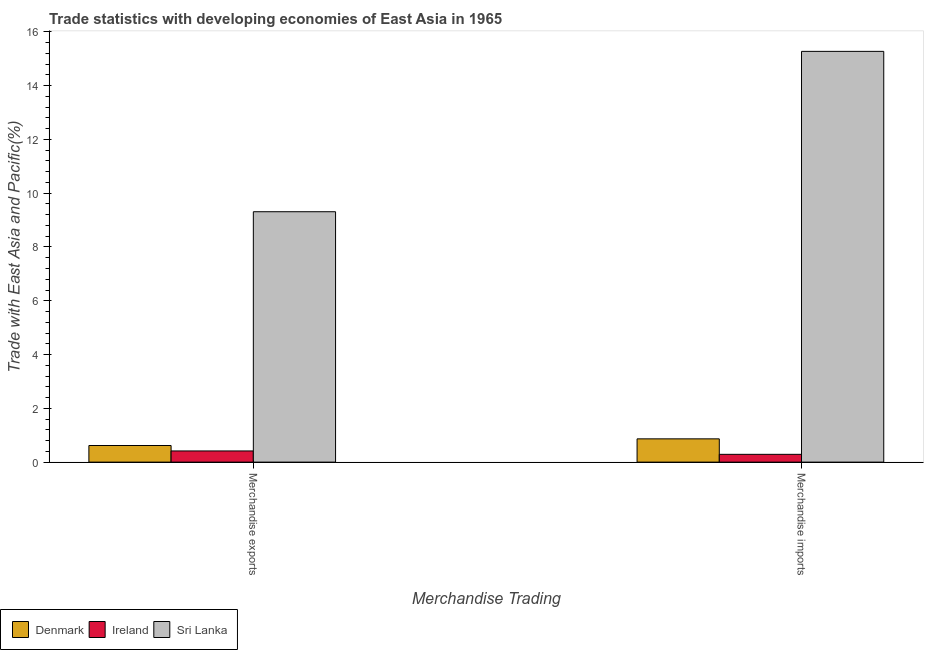How many different coloured bars are there?
Your answer should be compact. 3. How many groups of bars are there?
Your response must be concise. 2. How many bars are there on the 2nd tick from the left?
Offer a terse response. 3. What is the merchandise exports in Ireland?
Offer a terse response. 0.42. Across all countries, what is the maximum merchandise exports?
Offer a terse response. 9.31. Across all countries, what is the minimum merchandise exports?
Your answer should be very brief. 0.42. In which country was the merchandise exports maximum?
Offer a terse response. Sri Lanka. In which country was the merchandise imports minimum?
Your answer should be very brief. Ireland. What is the total merchandise exports in the graph?
Give a very brief answer. 10.34. What is the difference between the merchandise imports in Ireland and that in Denmark?
Make the answer very short. -0.58. What is the difference between the merchandise exports in Ireland and the merchandise imports in Sri Lanka?
Give a very brief answer. -14.86. What is the average merchandise imports per country?
Provide a short and direct response. 5.48. What is the difference between the merchandise exports and merchandise imports in Denmark?
Your answer should be very brief. -0.25. What is the ratio of the merchandise exports in Denmark to that in Sri Lanka?
Your answer should be very brief. 0.07. In how many countries, is the merchandise exports greater than the average merchandise exports taken over all countries?
Provide a short and direct response. 1. What does the 3rd bar from the left in Merchandise imports represents?
Your answer should be very brief. Sri Lanka. What does the 1st bar from the right in Merchandise imports represents?
Offer a very short reply. Sri Lanka. How many countries are there in the graph?
Your response must be concise. 3. What is the difference between two consecutive major ticks on the Y-axis?
Provide a succinct answer. 2. Are the values on the major ticks of Y-axis written in scientific E-notation?
Provide a short and direct response. No. Does the graph contain any zero values?
Provide a short and direct response. No. How many legend labels are there?
Keep it short and to the point. 3. What is the title of the graph?
Keep it short and to the point. Trade statistics with developing economies of East Asia in 1965. What is the label or title of the X-axis?
Your answer should be compact. Merchandise Trading. What is the label or title of the Y-axis?
Provide a succinct answer. Trade with East Asia and Pacific(%). What is the Trade with East Asia and Pacific(%) in Denmark in Merchandise exports?
Keep it short and to the point. 0.62. What is the Trade with East Asia and Pacific(%) in Ireland in Merchandise exports?
Your answer should be very brief. 0.42. What is the Trade with East Asia and Pacific(%) in Sri Lanka in Merchandise exports?
Your response must be concise. 9.31. What is the Trade with East Asia and Pacific(%) in Denmark in Merchandise imports?
Your response must be concise. 0.87. What is the Trade with East Asia and Pacific(%) in Ireland in Merchandise imports?
Your answer should be compact. 0.29. What is the Trade with East Asia and Pacific(%) in Sri Lanka in Merchandise imports?
Provide a succinct answer. 15.27. Across all Merchandise Trading, what is the maximum Trade with East Asia and Pacific(%) in Denmark?
Your answer should be compact. 0.87. Across all Merchandise Trading, what is the maximum Trade with East Asia and Pacific(%) in Ireland?
Offer a very short reply. 0.42. Across all Merchandise Trading, what is the maximum Trade with East Asia and Pacific(%) in Sri Lanka?
Provide a short and direct response. 15.27. Across all Merchandise Trading, what is the minimum Trade with East Asia and Pacific(%) of Denmark?
Your answer should be compact. 0.62. Across all Merchandise Trading, what is the minimum Trade with East Asia and Pacific(%) in Ireland?
Keep it short and to the point. 0.29. Across all Merchandise Trading, what is the minimum Trade with East Asia and Pacific(%) of Sri Lanka?
Offer a terse response. 9.31. What is the total Trade with East Asia and Pacific(%) of Denmark in the graph?
Offer a very short reply. 1.48. What is the total Trade with East Asia and Pacific(%) of Ireland in the graph?
Your answer should be compact. 0.7. What is the total Trade with East Asia and Pacific(%) of Sri Lanka in the graph?
Offer a very short reply. 24.59. What is the difference between the Trade with East Asia and Pacific(%) in Denmark in Merchandise exports and that in Merchandise imports?
Offer a terse response. -0.25. What is the difference between the Trade with East Asia and Pacific(%) in Ireland in Merchandise exports and that in Merchandise imports?
Your response must be concise. 0.13. What is the difference between the Trade with East Asia and Pacific(%) of Sri Lanka in Merchandise exports and that in Merchandise imports?
Keep it short and to the point. -5.96. What is the difference between the Trade with East Asia and Pacific(%) in Denmark in Merchandise exports and the Trade with East Asia and Pacific(%) in Ireland in Merchandise imports?
Provide a short and direct response. 0.33. What is the difference between the Trade with East Asia and Pacific(%) in Denmark in Merchandise exports and the Trade with East Asia and Pacific(%) in Sri Lanka in Merchandise imports?
Provide a short and direct response. -14.66. What is the difference between the Trade with East Asia and Pacific(%) of Ireland in Merchandise exports and the Trade with East Asia and Pacific(%) of Sri Lanka in Merchandise imports?
Your answer should be compact. -14.86. What is the average Trade with East Asia and Pacific(%) in Denmark per Merchandise Trading?
Offer a terse response. 0.74. What is the average Trade with East Asia and Pacific(%) of Ireland per Merchandise Trading?
Offer a terse response. 0.35. What is the average Trade with East Asia and Pacific(%) in Sri Lanka per Merchandise Trading?
Your response must be concise. 12.29. What is the difference between the Trade with East Asia and Pacific(%) of Denmark and Trade with East Asia and Pacific(%) of Ireland in Merchandise exports?
Make the answer very short. 0.2. What is the difference between the Trade with East Asia and Pacific(%) in Denmark and Trade with East Asia and Pacific(%) in Sri Lanka in Merchandise exports?
Provide a short and direct response. -8.69. What is the difference between the Trade with East Asia and Pacific(%) in Ireland and Trade with East Asia and Pacific(%) in Sri Lanka in Merchandise exports?
Your answer should be very brief. -8.9. What is the difference between the Trade with East Asia and Pacific(%) in Denmark and Trade with East Asia and Pacific(%) in Ireland in Merchandise imports?
Ensure brevity in your answer.  0.58. What is the difference between the Trade with East Asia and Pacific(%) of Denmark and Trade with East Asia and Pacific(%) of Sri Lanka in Merchandise imports?
Your answer should be compact. -14.41. What is the difference between the Trade with East Asia and Pacific(%) of Ireland and Trade with East Asia and Pacific(%) of Sri Lanka in Merchandise imports?
Offer a terse response. -14.99. What is the ratio of the Trade with East Asia and Pacific(%) in Denmark in Merchandise exports to that in Merchandise imports?
Your response must be concise. 0.71. What is the ratio of the Trade with East Asia and Pacific(%) of Ireland in Merchandise exports to that in Merchandise imports?
Provide a succinct answer. 1.44. What is the ratio of the Trade with East Asia and Pacific(%) of Sri Lanka in Merchandise exports to that in Merchandise imports?
Keep it short and to the point. 0.61. What is the difference between the highest and the second highest Trade with East Asia and Pacific(%) in Denmark?
Offer a terse response. 0.25. What is the difference between the highest and the second highest Trade with East Asia and Pacific(%) in Ireland?
Provide a short and direct response. 0.13. What is the difference between the highest and the second highest Trade with East Asia and Pacific(%) of Sri Lanka?
Your answer should be compact. 5.96. What is the difference between the highest and the lowest Trade with East Asia and Pacific(%) in Denmark?
Offer a terse response. 0.25. What is the difference between the highest and the lowest Trade with East Asia and Pacific(%) in Ireland?
Your response must be concise. 0.13. What is the difference between the highest and the lowest Trade with East Asia and Pacific(%) in Sri Lanka?
Keep it short and to the point. 5.96. 